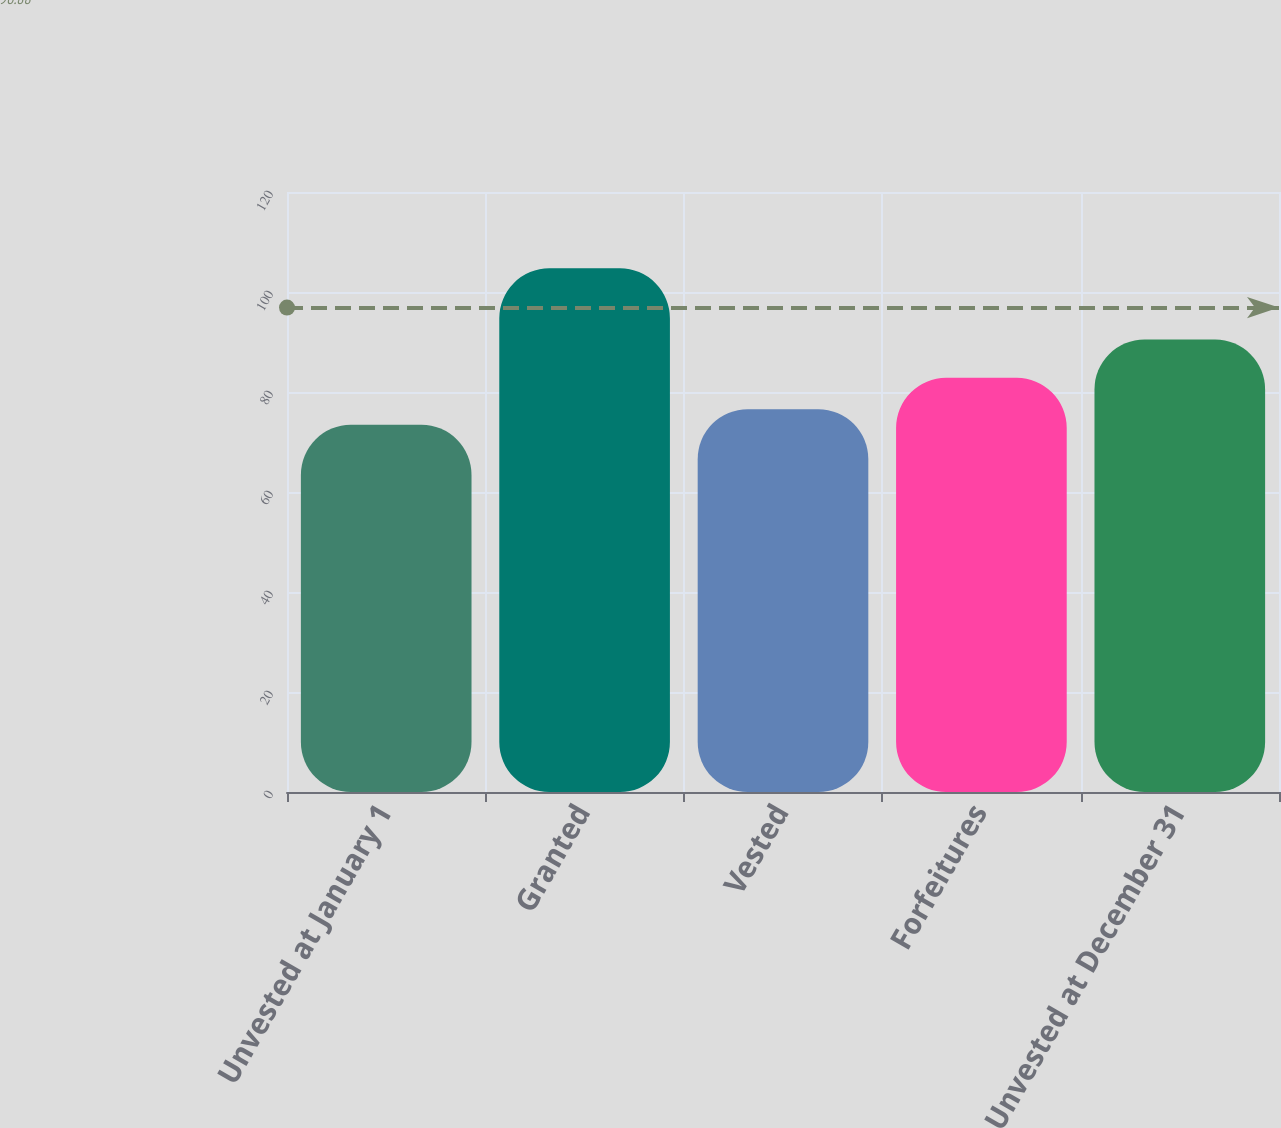<chart> <loc_0><loc_0><loc_500><loc_500><bar_chart><fcel>Unvested at January 1<fcel>Granted<fcel>Vested<fcel>Forfeitures<fcel>Unvested at December 31<nl><fcel>73.44<fcel>104.74<fcel>76.57<fcel>82.83<fcel>90.5<nl></chart> 